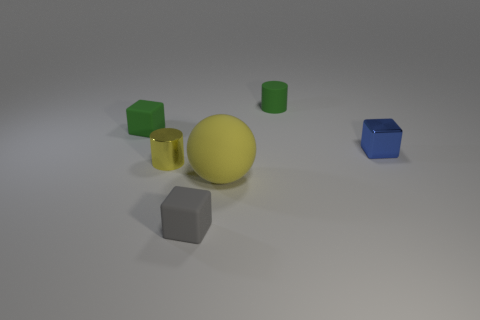Subtract all tiny rubber cubes. How many cubes are left? 1 Add 2 yellow matte spheres. How many objects exist? 8 Subtract all cylinders. How many objects are left? 4 Subtract all large cyan objects. Subtract all blue cubes. How many objects are left? 5 Add 3 gray matte cubes. How many gray matte cubes are left? 4 Add 1 green rubber cubes. How many green rubber cubes exist? 2 Subtract 0 red blocks. How many objects are left? 6 